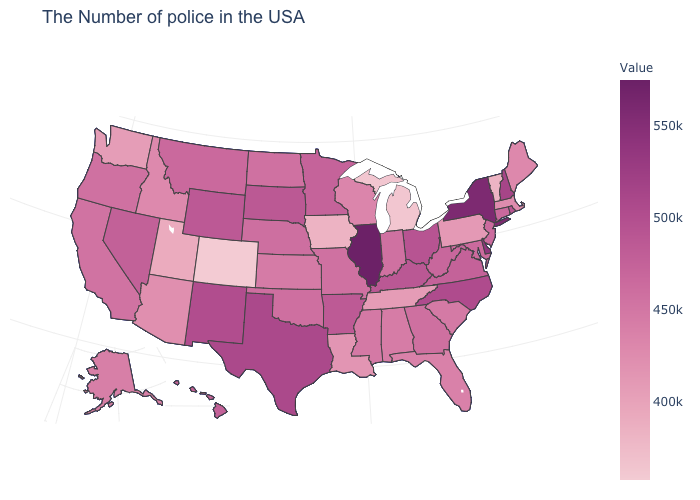Does the map have missing data?
Short answer required. No. Is the legend a continuous bar?
Quick response, please. Yes. Does the map have missing data?
Keep it brief. No. Does Delaware have the highest value in the South?
Keep it brief. Yes. Is the legend a continuous bar?
Give a very brief answer. Yes. Which states have the highest value in the USA?
Be succinct. Illinois. 